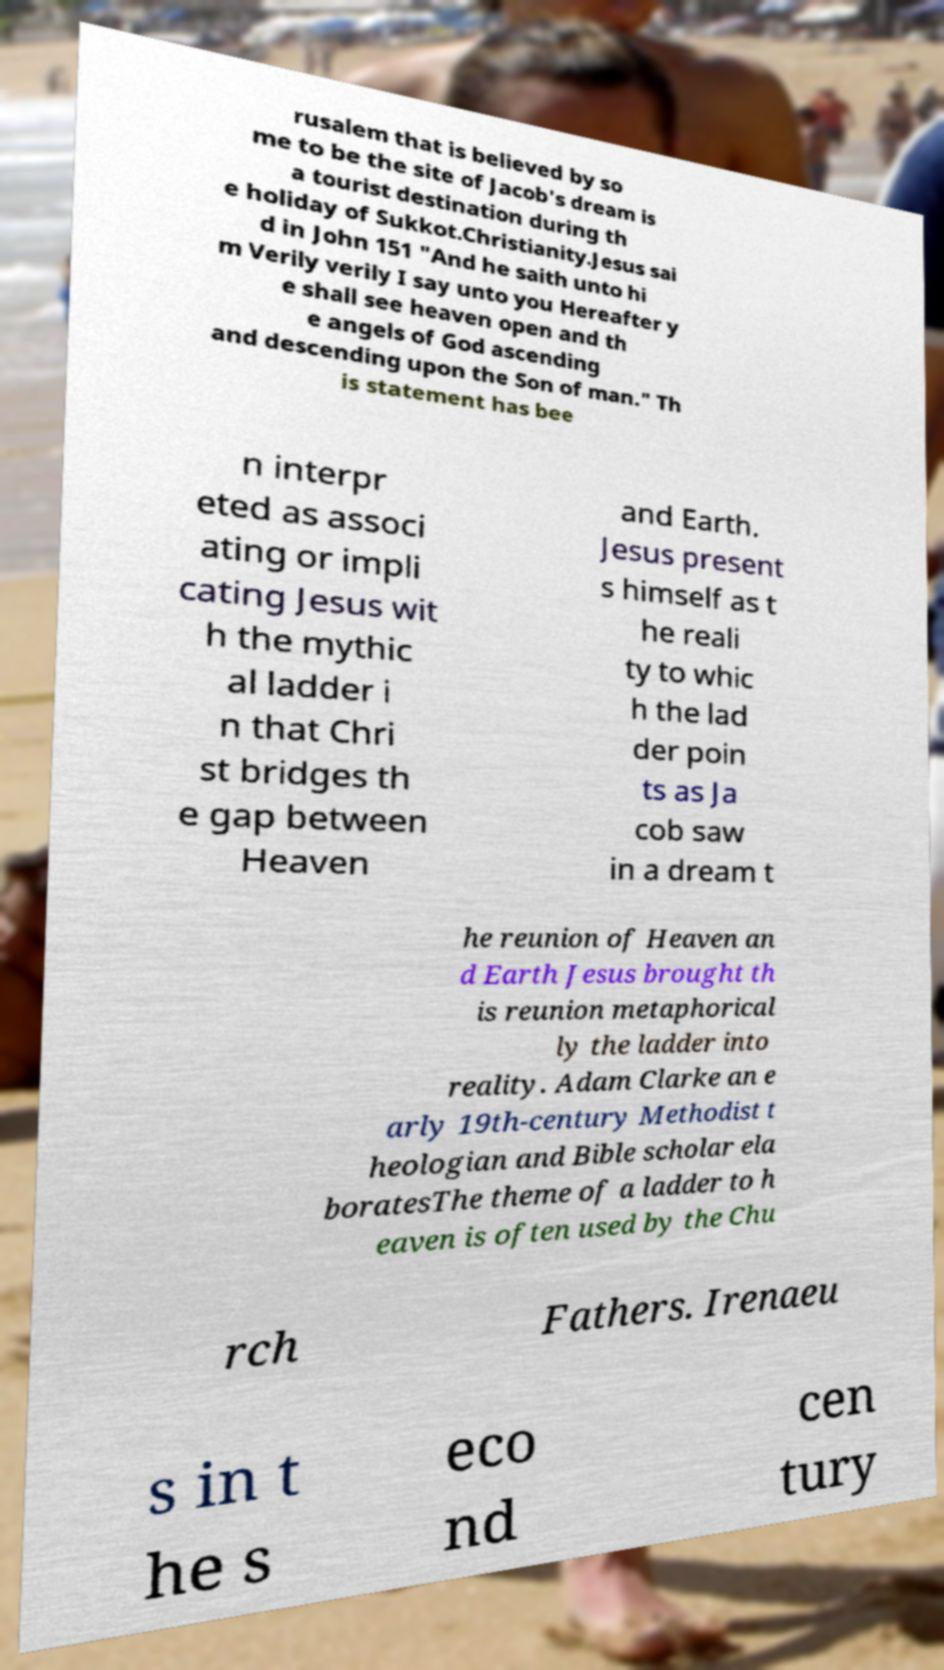Can you accurately transcribe the text from the provided image for me? rusalem that is believed by so me to be the site of Jacob's dream is a tourist destination during th e holiday of Sukkot.Christianity.Jesus sai d in John 151 "And he saith unto hi m Verily verily I say unto you Hereafter y e shall see heaven open and th e angels of God ascending and descending upon the Son of man." Th is statement has bee n interpr eted as associ ating or impli cating Jesus wit h the mythic al ladder i n that Chri st bridges th e gap between Heaven and Earth. Jesus present s himself as t he reali ty to whic h the lad der poin ts as Ja cob saw in a dream t he reunion of Heaven an d Earth Jesus brought th is reunion metaphorical ly the ladder into reality. Adam Clarke an e arly 19th-century Methodist t heologian and Bible scholar ela boratesThe theme of a ladder to h eaven is often used by the Chu rch Fathers. Irenaeu s in t he s eco nd cen tury 